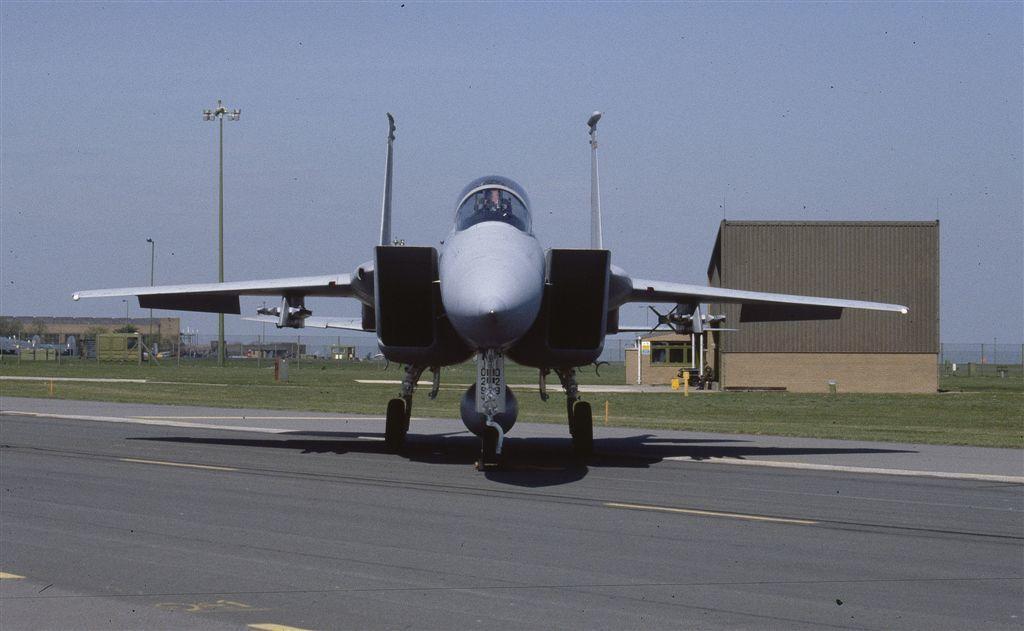Can you describe this image briefly? In the center of the image an airplane is there. In the background of the image we can see houses, truck, mesh, electric light poles, ground. At the top of the image there is a sky. At the bottom of the image there is a road. 